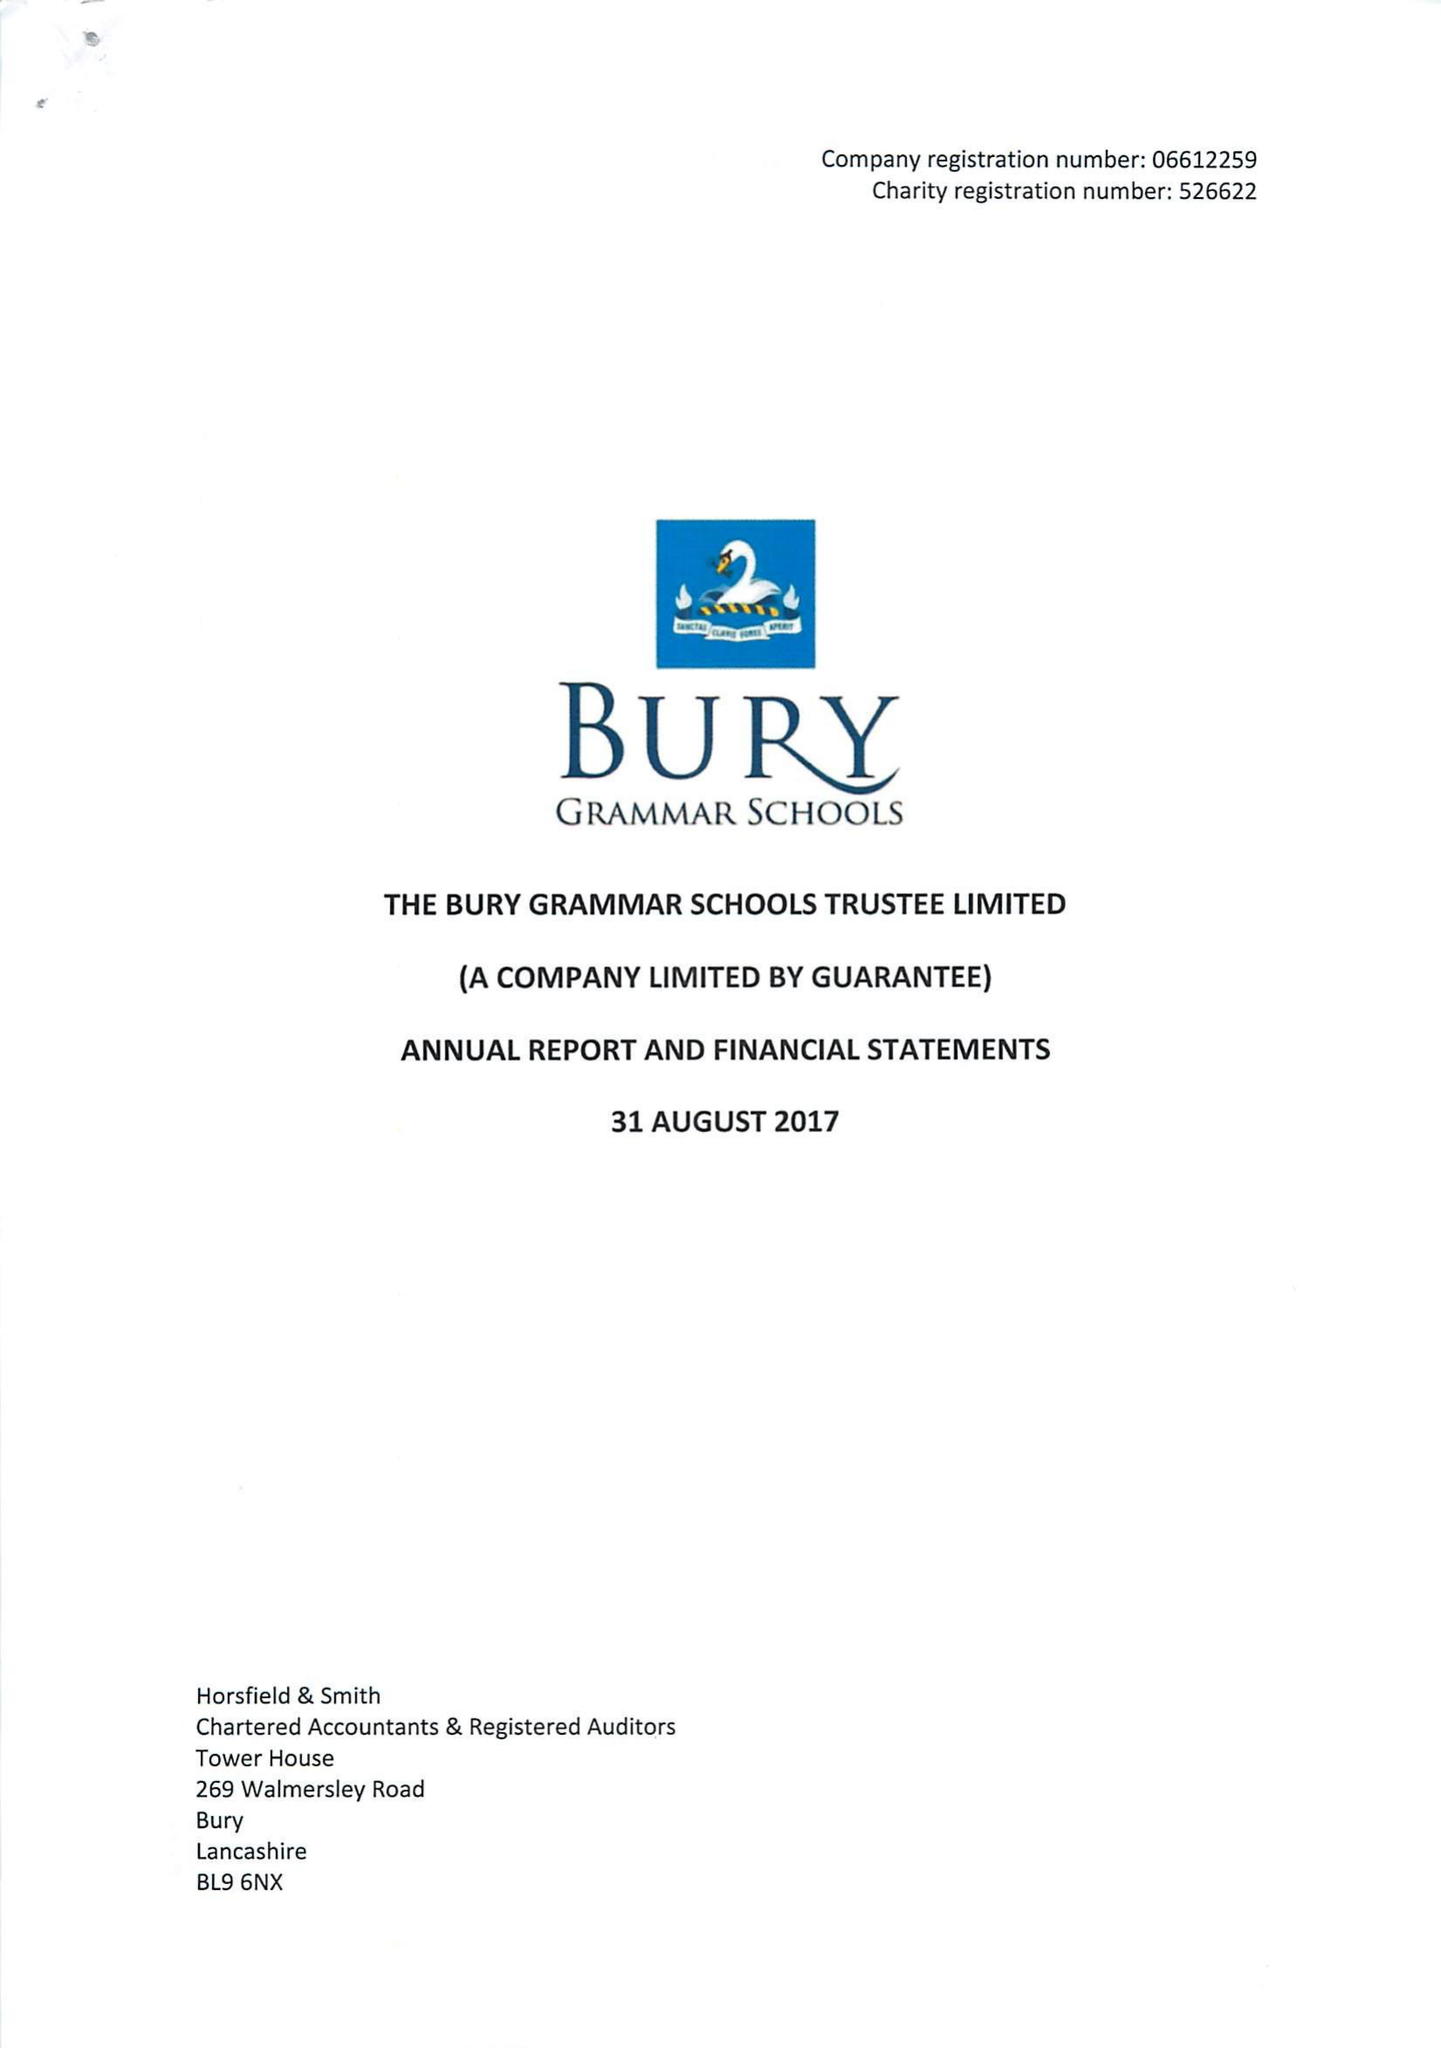What is the value for the charity_number?
Answer the question using a single word or phrase. 526622 